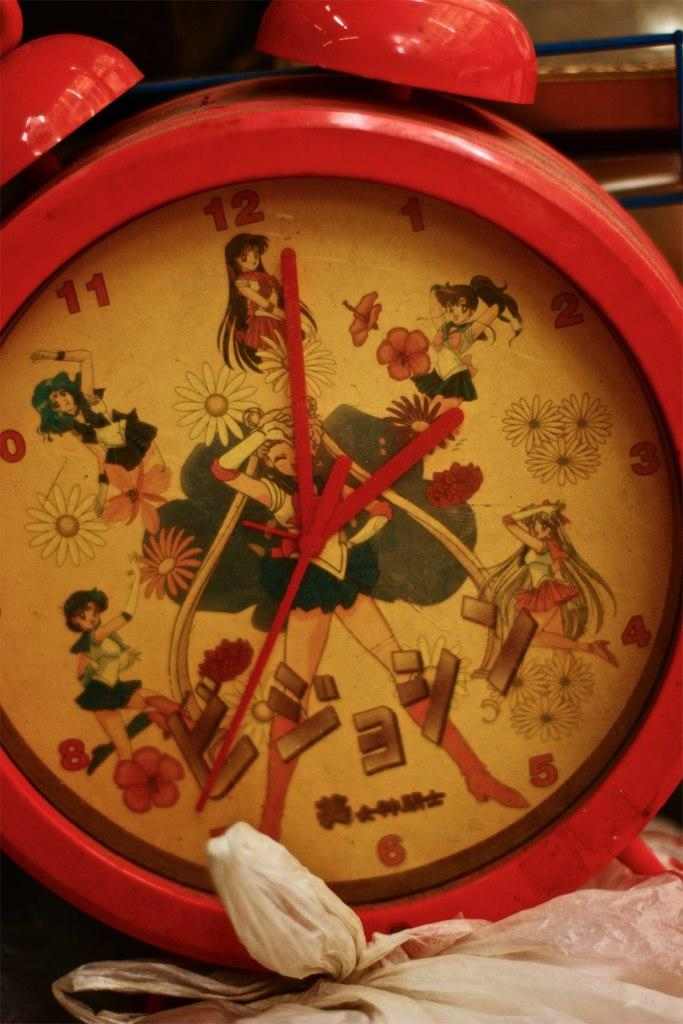<image>
Give a short and clear explanation of the subsequent image. A red Japanese themed alarm clock tells us it is just after 2 o'clock. 